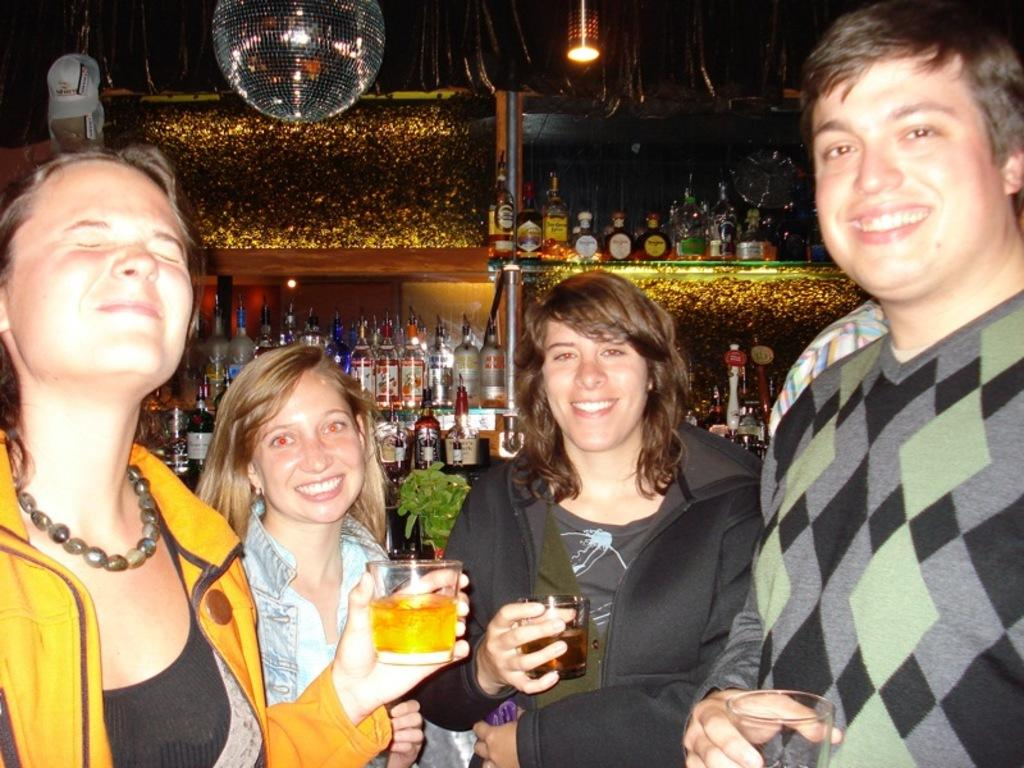What are the people in the image doing? The people in the image are standing and holding glasses. What objects can be seen in the background of the image? There are bottles and lights visible in the background of the image. Can you see an army of snakes in the image? No, there are no snakes or army present in the image. 